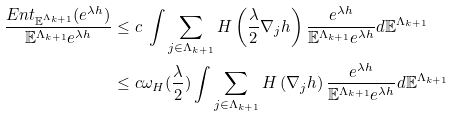<formula> <loc_0><loc_0><loc_500><loc_500>\frac { E n t _ { \mathbb { E } ^ { \Lambda _ { k + 1 } } } ( e ^ { \lambda h } ) } { \mathbb { E } ^ { \Lambda _ { k + 1 } } e ^ { \lambda h } } & \leq c \ \int \sum _ { j \in \Lambda _ { k + 1 } } H \left ( \frac { \lambda } { 2 } \nabla _ { j } h \right ) \frac { e ^ { \lambda h } } { \mathbb { E } ^ { \Lambda _ { k + 1 } } e ^ { \lambda h } } d \mathbb { E } ^ { \Lambda _ { k + 1 } } \\ & \leq c \omega _ { H } ( \frac { \lambda } { 2 } ) \int \sum _ { j \in \Lambda _ { k + 1 } } H \left ( \nabla _ { j } h \right ) \frac { e ^ { \lambda h } } { \mathbb { E } ^ { \Lambda _ { k + 1 } } e ^ { \lambda h } } d \mathbb { E } ^ { \Lambda _ { k + 1 } }</formula> 